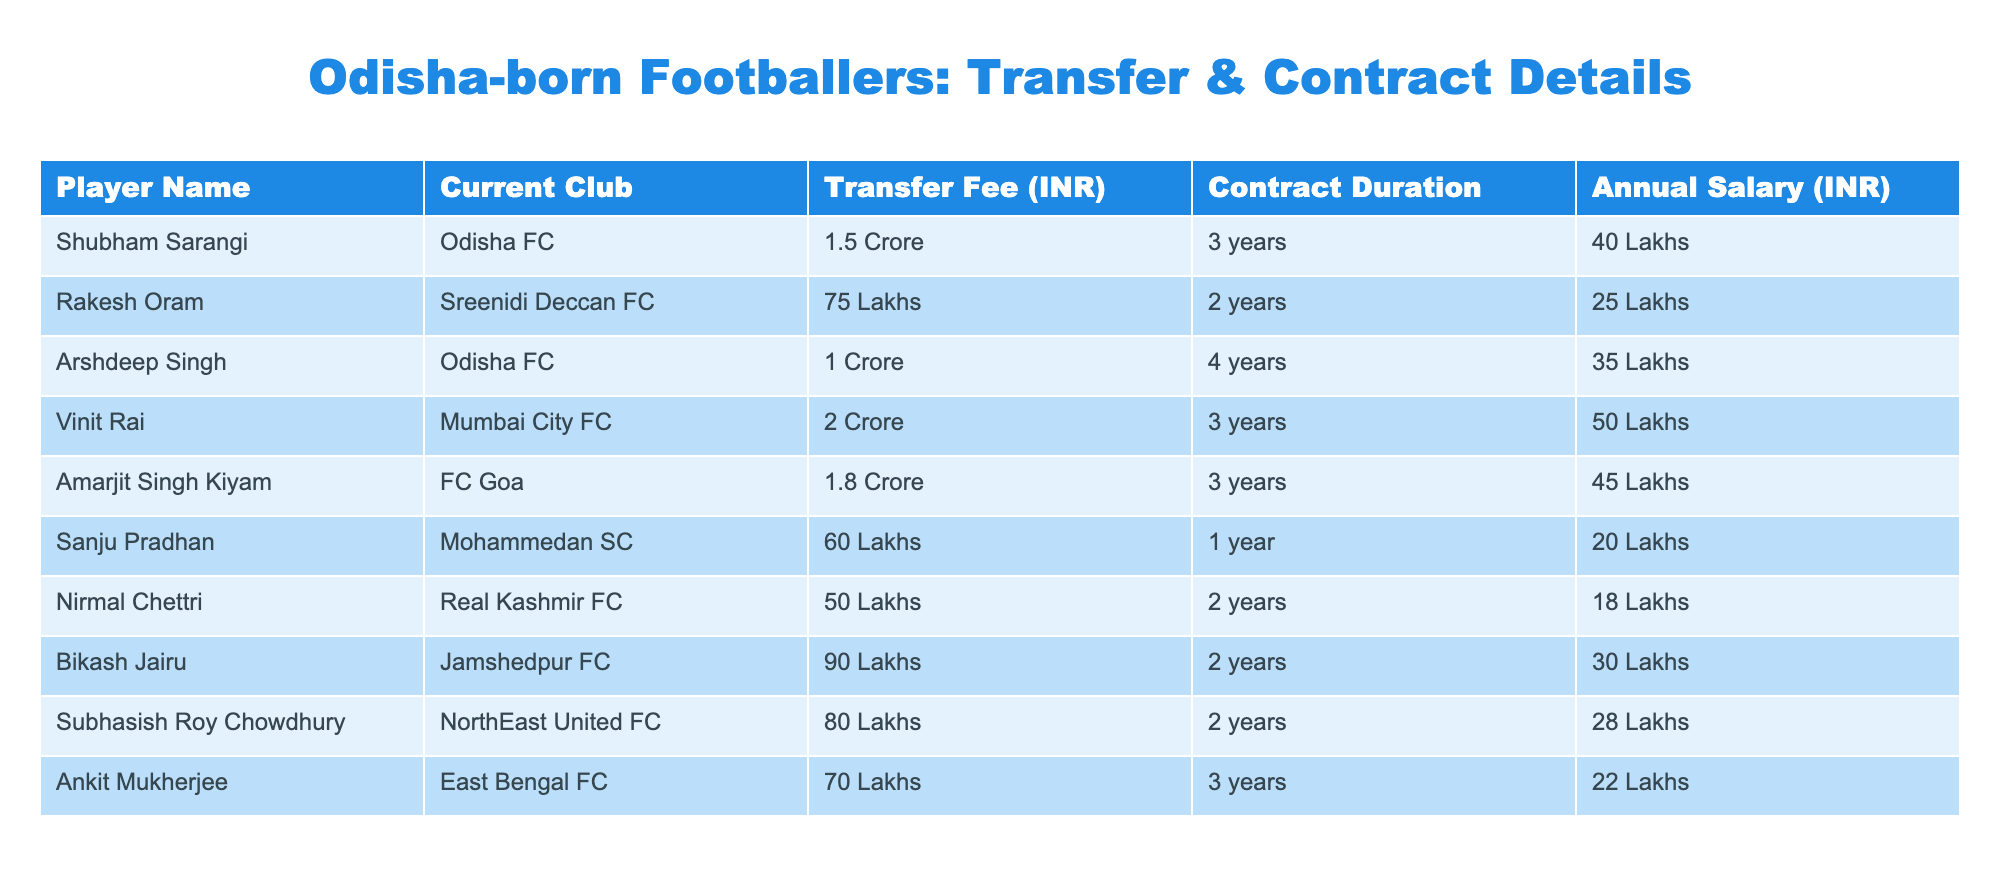What is the highest transfer fee recorded for an Odisha-born footballer? By reviewing the "Transfer Fee (INR)" column, I see that Vinit Rai has the highest transfer fee, which is noted as "2 Crore".
Answer: 2 Crore How many years is Amarjit Singh Kiyam's contract duration? Looking at the "Contract Duration" column, Amarjit Singh Kiyam is listed with a contract duration of "3 years".
Answer: 3 years What is the total annual salary of all footballers in the table? To find the total annual salary, I add the annual salaries: 40 + 25 + 35 + 50 + 45 + 20 + 18 + 30 + 28 + 22 =  393 Lakhs.
Answer: 393 Lakhs Is Sanju Pradhan earning more than Nirmal Chettri? Checking the "Annual Salary (INR)" for Sanju Pradhan (20 Lakhs) and Nirmal Chettri (18 Lakhs), I find that 20 Lakhs is greater than 18 Lakhs, confirming he earns more.
Answer: Yes How many players have a contract duration of 2 years? I review the "Contract Duration" column and count the players with "2 years", which includes Rakesh Oram, Nirmal Chettri, Bikash Jairu, and Subhasish Roy Chowdhury, totaling 4 players.
Answer: 4 players What is the average transfer fee of players with contracts lasting 3 years? First, I filter the players with a contract duration of 3 years: Shubham Sarangi (1.5 Crore), Vinit Rai (2 Crore), and Amarjit Singh Kiyam (1.8 Crore). Summing these gives 1.5 + 2 + 1.8 = 5.3 Crore. Dividing by 3 gives an average of 1.76667 Crore.
Answer: 1.77 Crore Which player has the lowest annual salary? I look through the "Annual Salary (INR)" column, and find that Nirmal Chettri has the lowest salary at "18 Lakhs".
Answer: 18 Lakhs What is the total transfer fee of all footballers who play for Odisha FC? From the table, the footballers for Odisha FC are Shubham Sarangi (1.5 Crore) and Arshdeep Singh (1 Crore). Adding these gives 1.5 + 1 = 2.5 Crore.
Answer: 2.5 Crore Are there any players who have an annual salary exceeding 30 Lakhs? Reviewing the "Annual Salary (INR)", I see that Shubham Sarangi (40 Lakhs), Vinit Rai (50 Lakhs), Amarjit Singh Kiyam (45 Lakhs), and Bikash Jairu (30 Lakhs) all exceed 30 Lakhs, confirming there are indeed players meeting this criterion.
Answer: Yes 